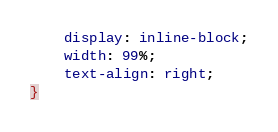<code> <loc_0><loc_0><loc_500><loc_500><_CSS_>    display: inline-block;
    width: 99%;
    text-align: right;
}
</code> 